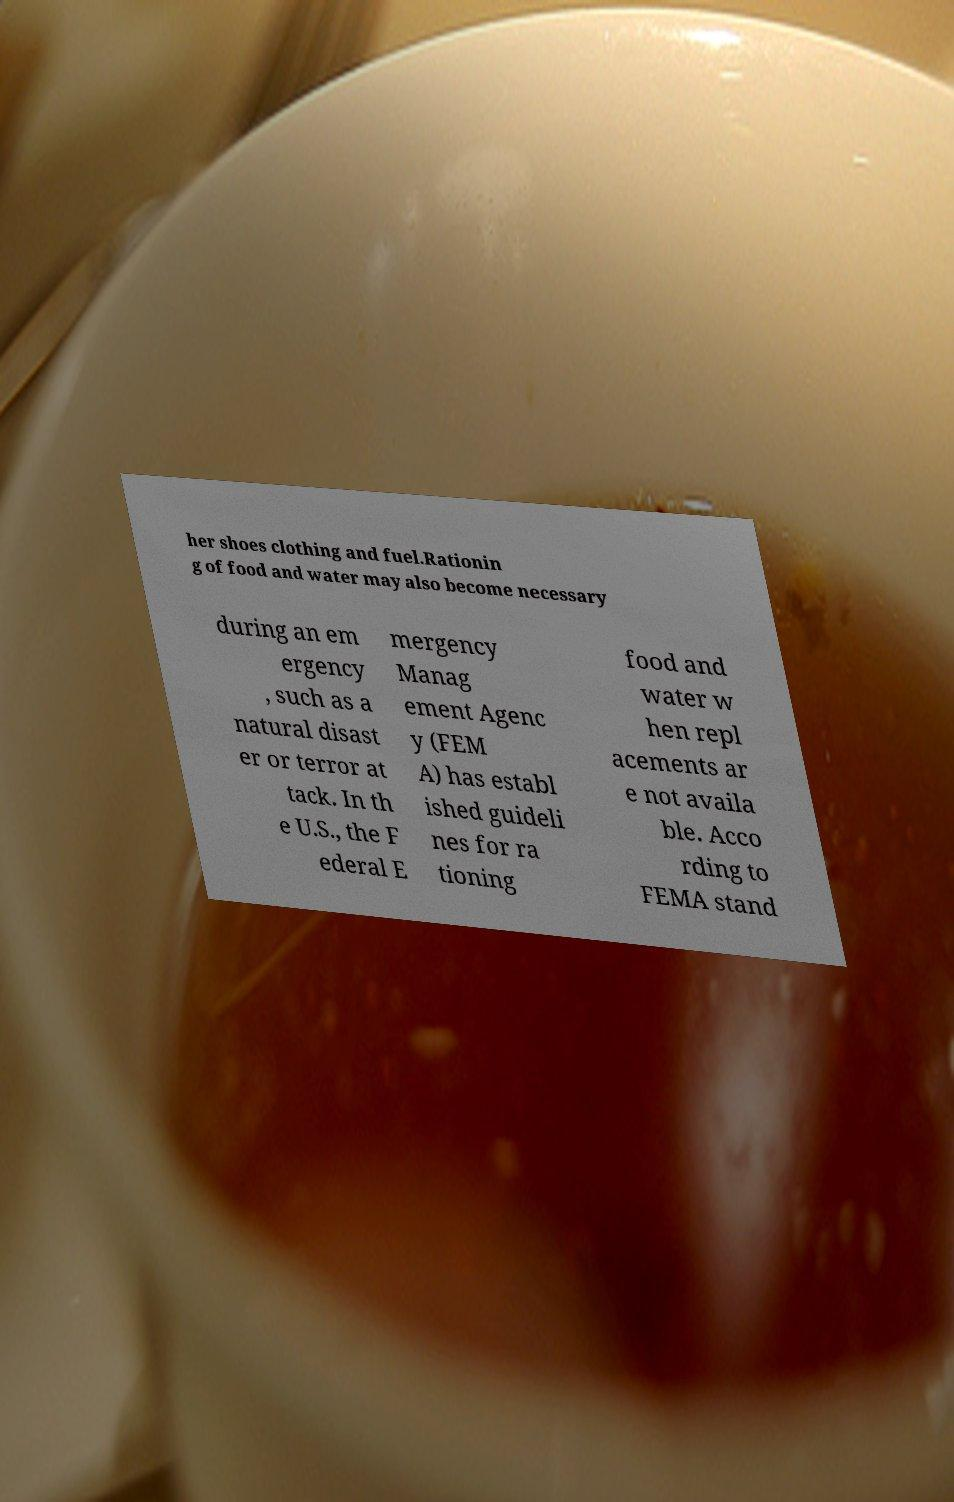Can you accurately transcribe the text from the provided image for me? her shoes clothing and fuel.Rationin g of food and water may also become necessary during an em ergency , such as a natural disast er or terror at tack. In th e U.S., the F ederal E mergency Manag ement Agenc y (FEM A) has establ ished guideli nes for ra tioning food and water w hen repl acements ar e not availa ble. Acco rding to FEMA stand 